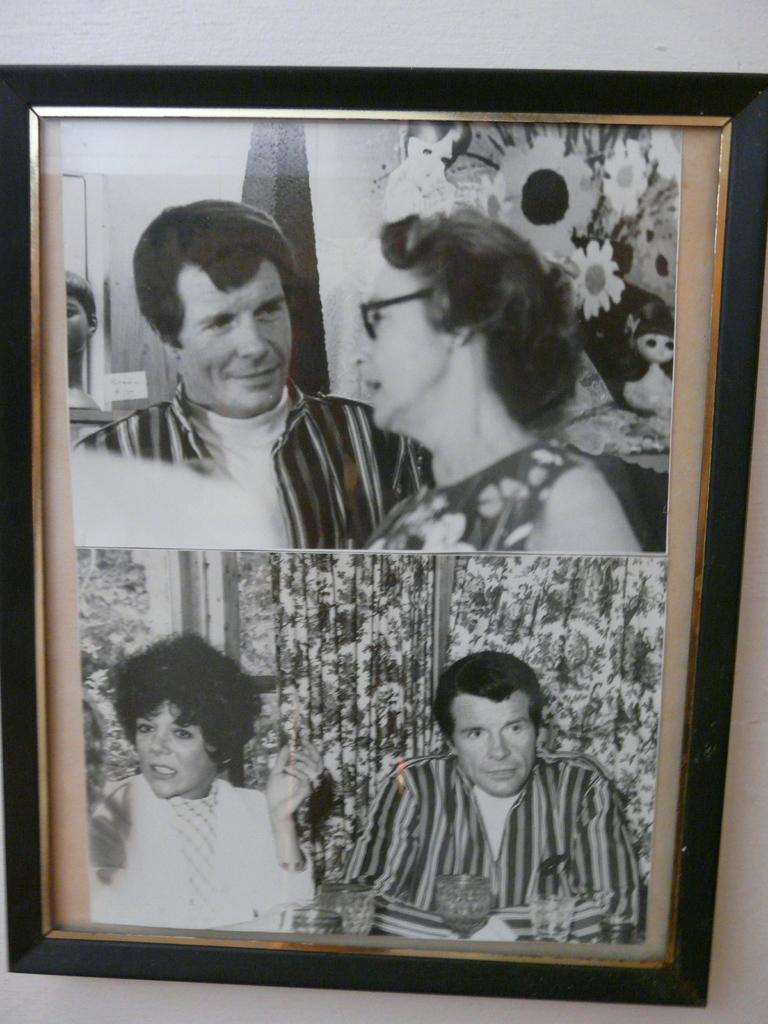What object in the image has black borders? There is a photo frame in the image with black borders. How many photographs are in the photo frame? There are two photographs in the photo frame. What can be seen in the first photograph? The first photograph is of a man. What can be seen in the second photograph? The second photograph is of a woman. What type of trail can be seen in the image? There is no trail present in the image; it features a photo frame with two photographs. 